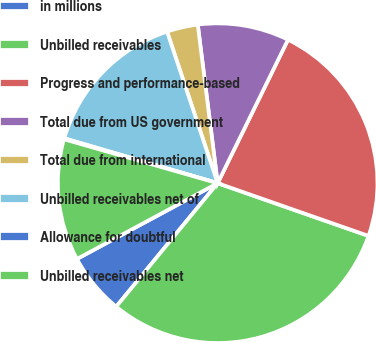<chart> <loc_0><loc_0><loc_500><loc_500><pie_chart><fcel>in millions<fcel>Unbilled receivables<fcel>Progress and performance-based<fcel>Total due from US government<fcel>Total due from international<fcel>Unbilled receivables net of<fcel>Allowance for doubtful<fcel>Unbilled receivables net<nl><fcel>6.19%<fcel>30.59%<fcel>23.09%<fcel>9.24%<fcel>3.14%<fcel>15.34%<fcel>0.1%<fcel>12.29%<nl></chart> 